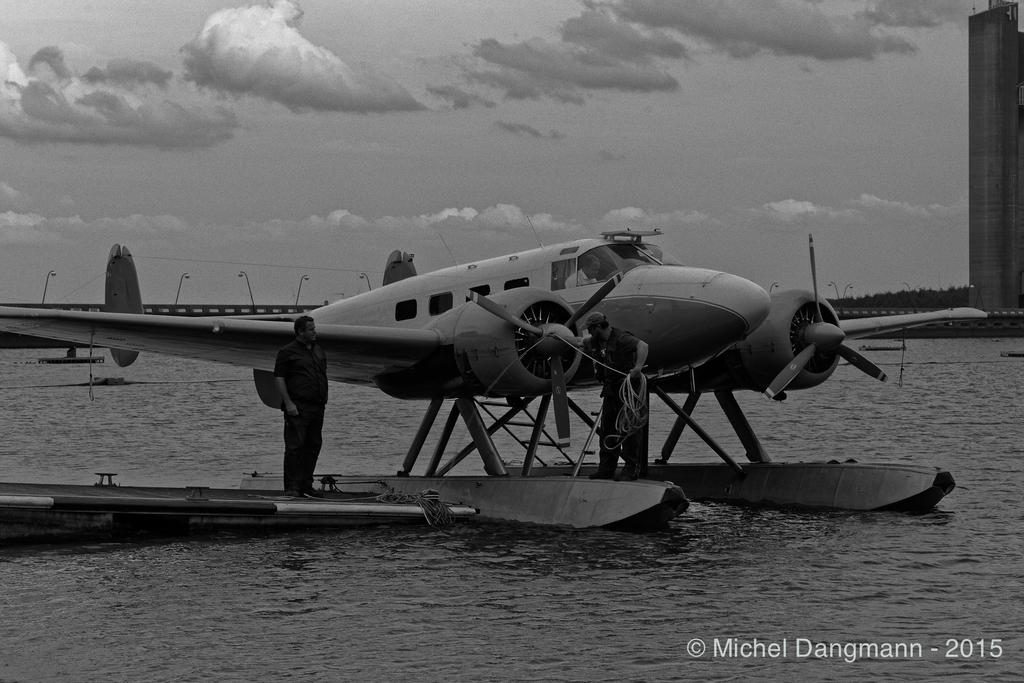<image>
Render a clear and concise summary of the photo. Black and white photo of a plane taken by Michel Dangmann. 